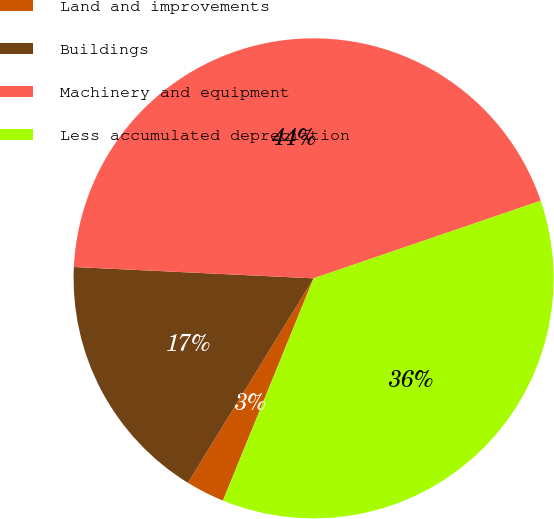Convert chart. <chart><loc_0><loc_0><loc_500><loc_500><pie_chart><fcel>Land and improvements<fcel>Buildings<fcel>Machinery and equipment<fcel>Less accumulated depreciation<nl><fcel>2.61%<fcel>16.98%<fcel>44.01%<fcel>36.4%<nl></chart> 